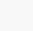Convert code to text. <code><loc_0><loc_0><loc_500><loc_500><_Python_>

    
</code> 